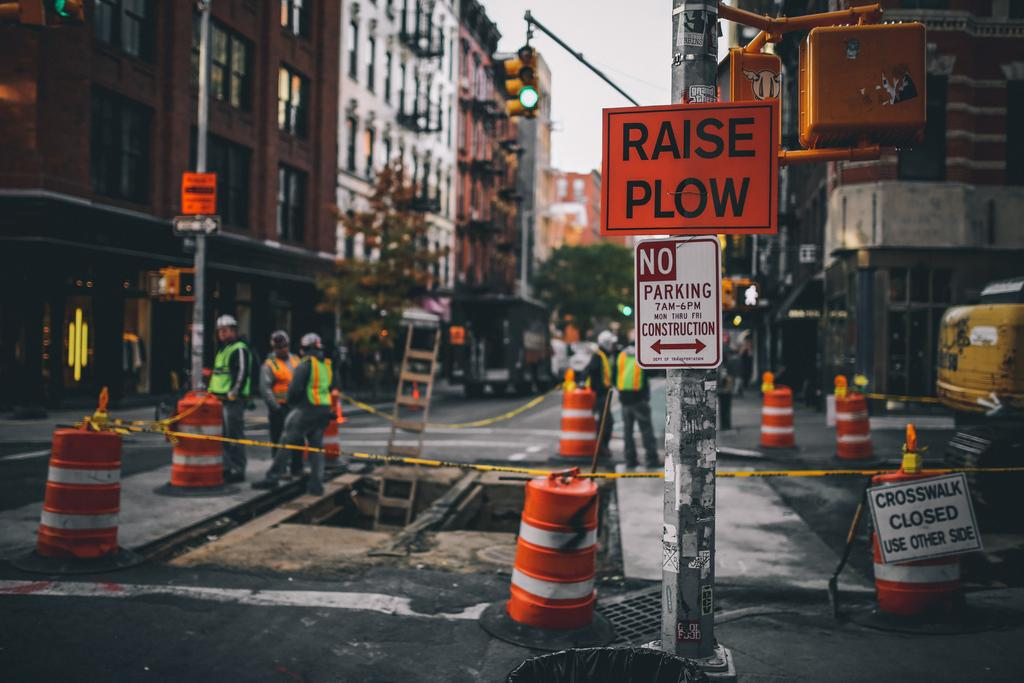<image>
Offer a succinct explanation of the picture presented. a raise plow sign that is on the street 